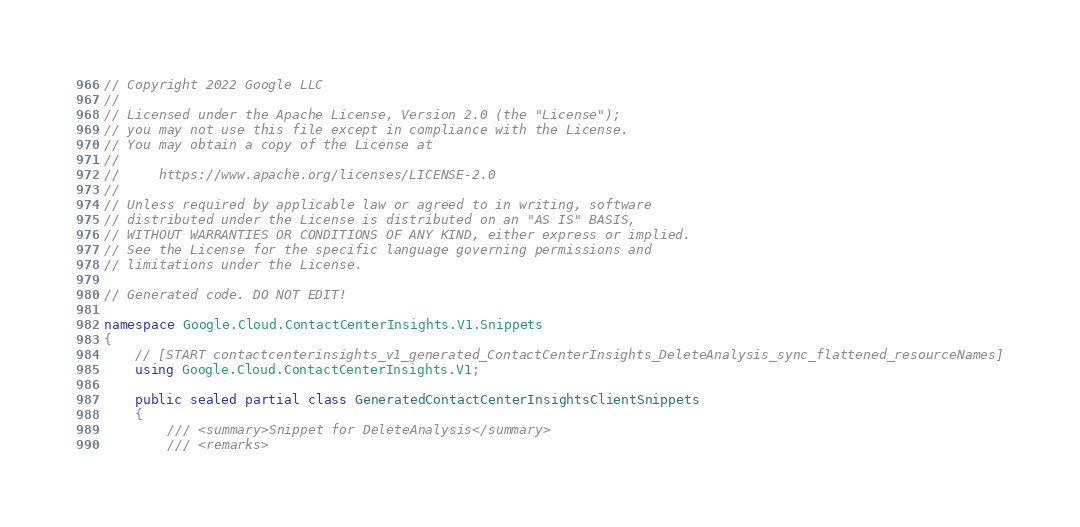<code> <loc_0><loc_0><loc_500><loc_500><_C#_>// Copyright 2022 Google LLC
//
// Licensed under the Apache License, Version 2.0 (the "License");
// you may not use this file except in compliance with the License.
// You may obtain a copy of the License at
//
//     https://www.apache.org/licenses/LICENSE-2.0
//
// Unless required by applicable law or agreed to in writing, software
// distributed under the License is distributed on an "AS IS" BASIS,
// WITHOUT WARRANTIES OR CONDITIONS OF ANY KIND, either express or implied.
// See the License for the specific language governing permissions and
// limitations under the License.

// Generated code. DO NOT EDIT!

namespace Google.Cloud.ContactCenterInsights.V1.Snippets
{
    // [START contactcenterinsights_v1_generated_ContactCenterInsights_DeleteAnalysis_sync_flattened_resourceNames]
    using Google.Cloud.ContactCenterInsights.V1;

    public sealed partial class GeneratedContactCenterInsightsClientSnippets
    {
        /// <summary>Snippet for DeleteAnalysis</summary>
        /// <remarks></code> 